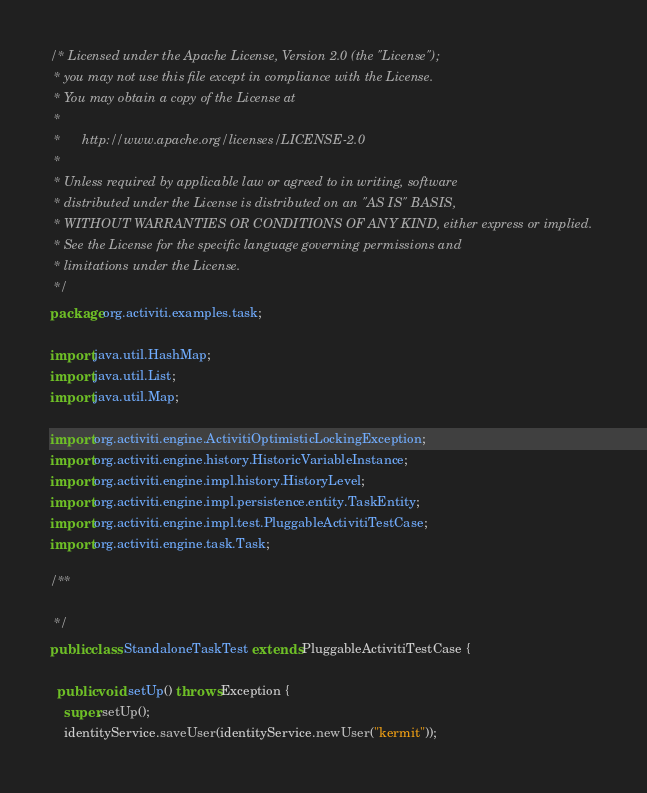Convert code to text. <code><loc_0><loc_0><loc_500><loc_500><_Java_>/* Licensed under the Apache License, Version 2.0 (the "License");
 * you may not use this file except in compliance with the License.
 * You may obtain a copy of the License at
 * 
 *      http://www.apache.org/licenses/LICENSE-2.0
 * 
 * Unless required by applicable law or agreed to in writing, software
 * distributed under the License is distributed on an "AS IS" BASIS,
 * WITHOUT WARRANTIES OR CONDITIONS OF ANY KIND, either express or implied.
 * See the License for the specific language governing permissions and
 * limitations under the License.
 */
package org.activiti.examples.task;

import java.util.HashMap;
import java.util.List;
import java.util.Map;

import org.activiti.engine.ActivitiOptimisticLockingException;
import org.activiti.engine.history.HistoricVariableInstance;
import org.activiti.engine.impl.history.HistoryLevel;
import org.activiti.engine.impl.persistence.entity.TaskEntity;
import org.activiti.engine.impl.test.PluggableActivitiTestCase;
import org.activiti.engine.task.Task;

/**

 */
public class StandaloneTaskTest extends PluggableActivitiTestCase {

  public void setUp() throws Exception {
    super.setUp();
    identityService.saveUser(identityService.newUser("kermit"));</code> 